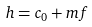<formula> <loc_0><loc_0><loc_500><loc_500>h = c _ { 0 } + m f</formula> 